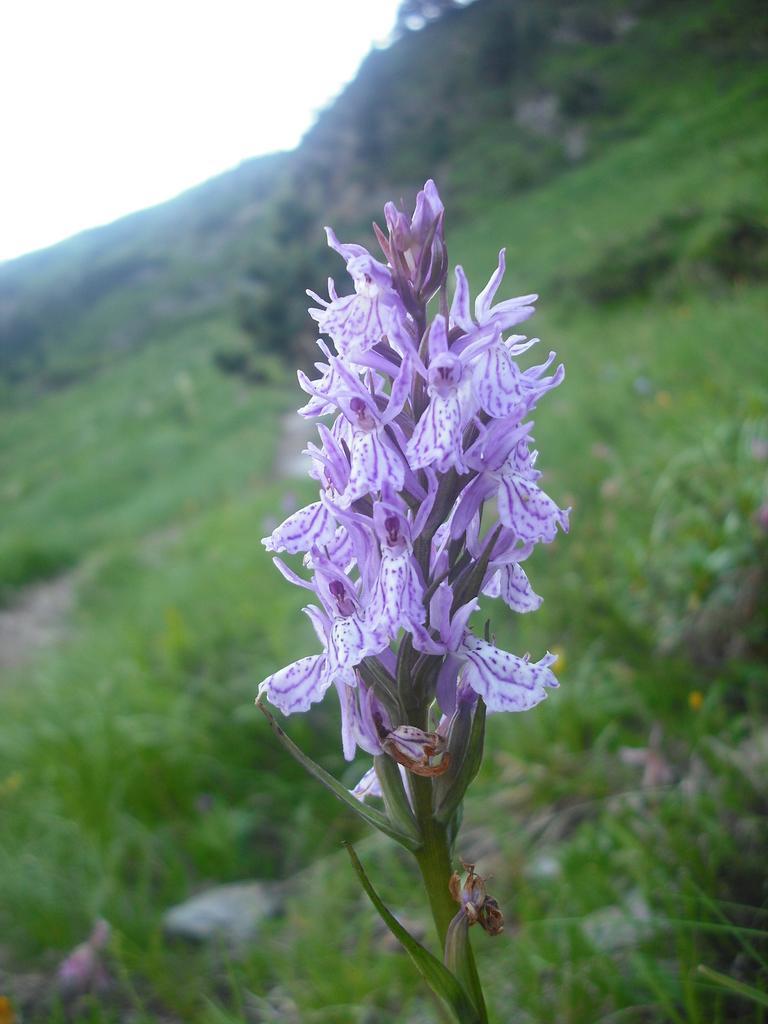Can you describe this image briefly? In this image we can see flowers on a stem. In the background it is green and blur. 